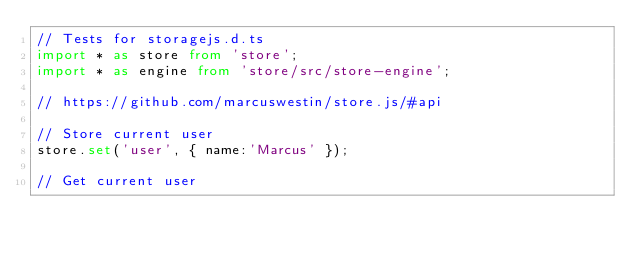<code> <loc_0><loc_0><loc_500><loc_500><_TypeScript_>// Tests for storagejs.d.ts
import * as store from 'store';
import * as engine from 'store/src/store-engine';

// https://github.com/marcuswestin/store.js/#api

// Store current user
store.set('user', { name:'Marcus' });

// Get current user</code> 